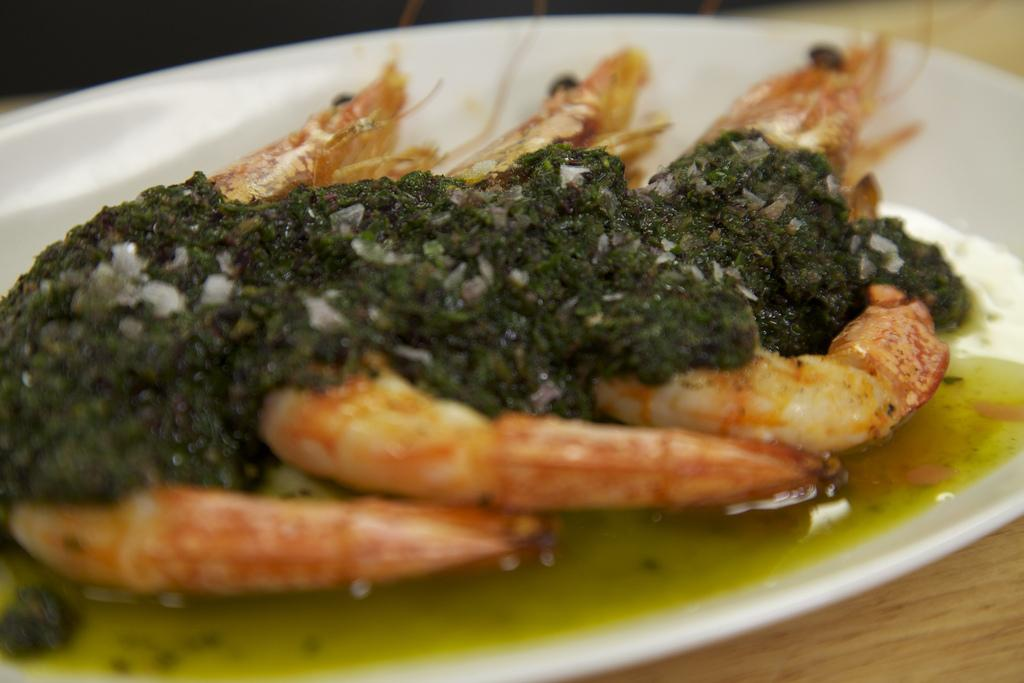What is located in the foreground of the image? There is a plate in the foreground of the image. What is on the plate? There is food on the plate. What piece of furniture is present in the image? There is a table in the image. How many accounts are visible on the shelf in the image? There is no shelf or accounts present in the image; it only features a plate with food and a table. 